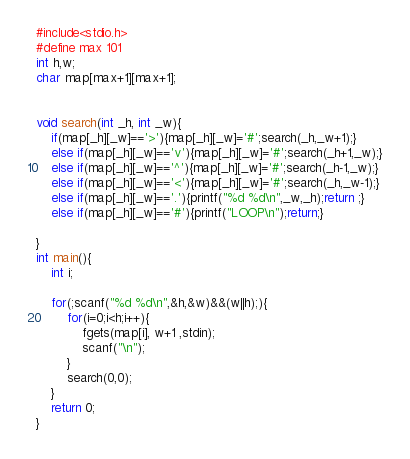<code> <loc_0><loc_0><loc_500><loc_500><_C_>#include<stdio.h>
#define max 101
int h,w;
char map[max+1][max+1];


void search(int _h, int _w){
	if(map[_h][_w]=='>'){map[_h][_w]='#';search(_h,_w+1);}
	else if(map[_h][_w]=='v'){map[_h][_w]='#';search(_h+1,_w);}
	else if(map[_h][_w]=='^'){map[_h][_w]='#';search(_h-1,_w);}
	else if(map[_h][_w]=='<'){map[_h][_w]='#';search(_h,_w-1);}
	else if(map[_h][_w]=='.'){printf("%d %d\n",_w,_h);return ;}
	else if(map[_h][_w]=='#'){printf("LOOP\n");return;}
	
}
int main(){
	int i;
	
	for(;scanf("%d %d\n",&h,&w)&&(w||h);){
		for(i=0;i<h;i++){
			fgets(map[i], w+1 ,stdin);
			scanf("\n");
		}
		search(0,0);
	}
	return 0;
}</code> 